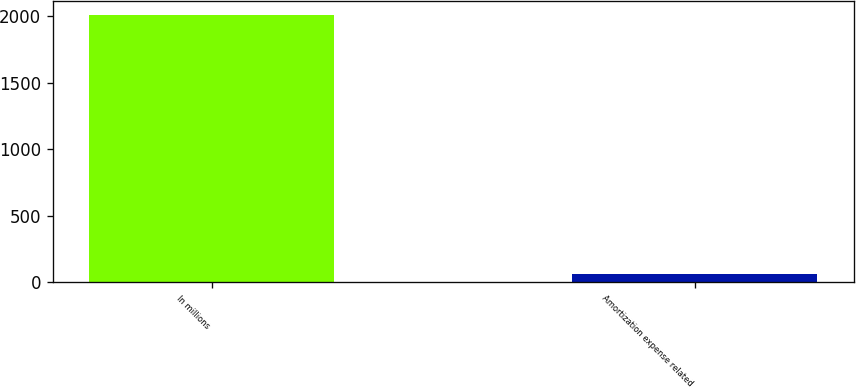Convert chart. <chart><loc_0><loc_0><loc_500><loc_500><bar_chart><fcel>In millions<fcel>Amortization expense related<nl><fcel>2012<fcel>58<nl></chart> 